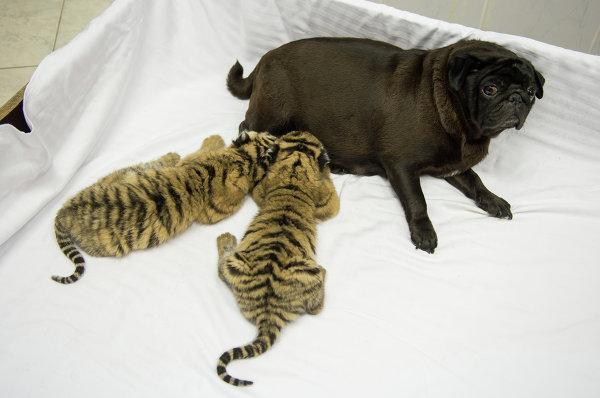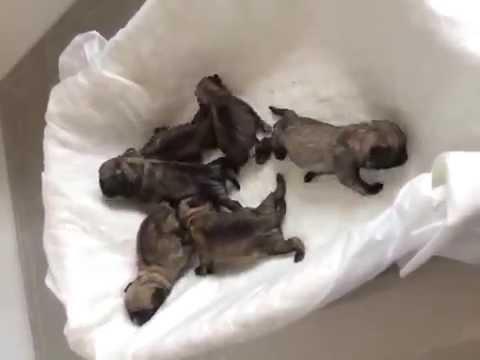The first image is the image on the left, the second image is the image on the right. Given the left and right images, does the statement "Two striped cats are nursing on a dog in one of the images." hold true? Answer yes or no. Yes. The first image is the image on the left, the second image is the image on the right. For the images displayed, is the sentence "Two baby animals with tiger stripes are nursing a reclining pug dog in one image." factually correct? Answer yes or no. Yes. 